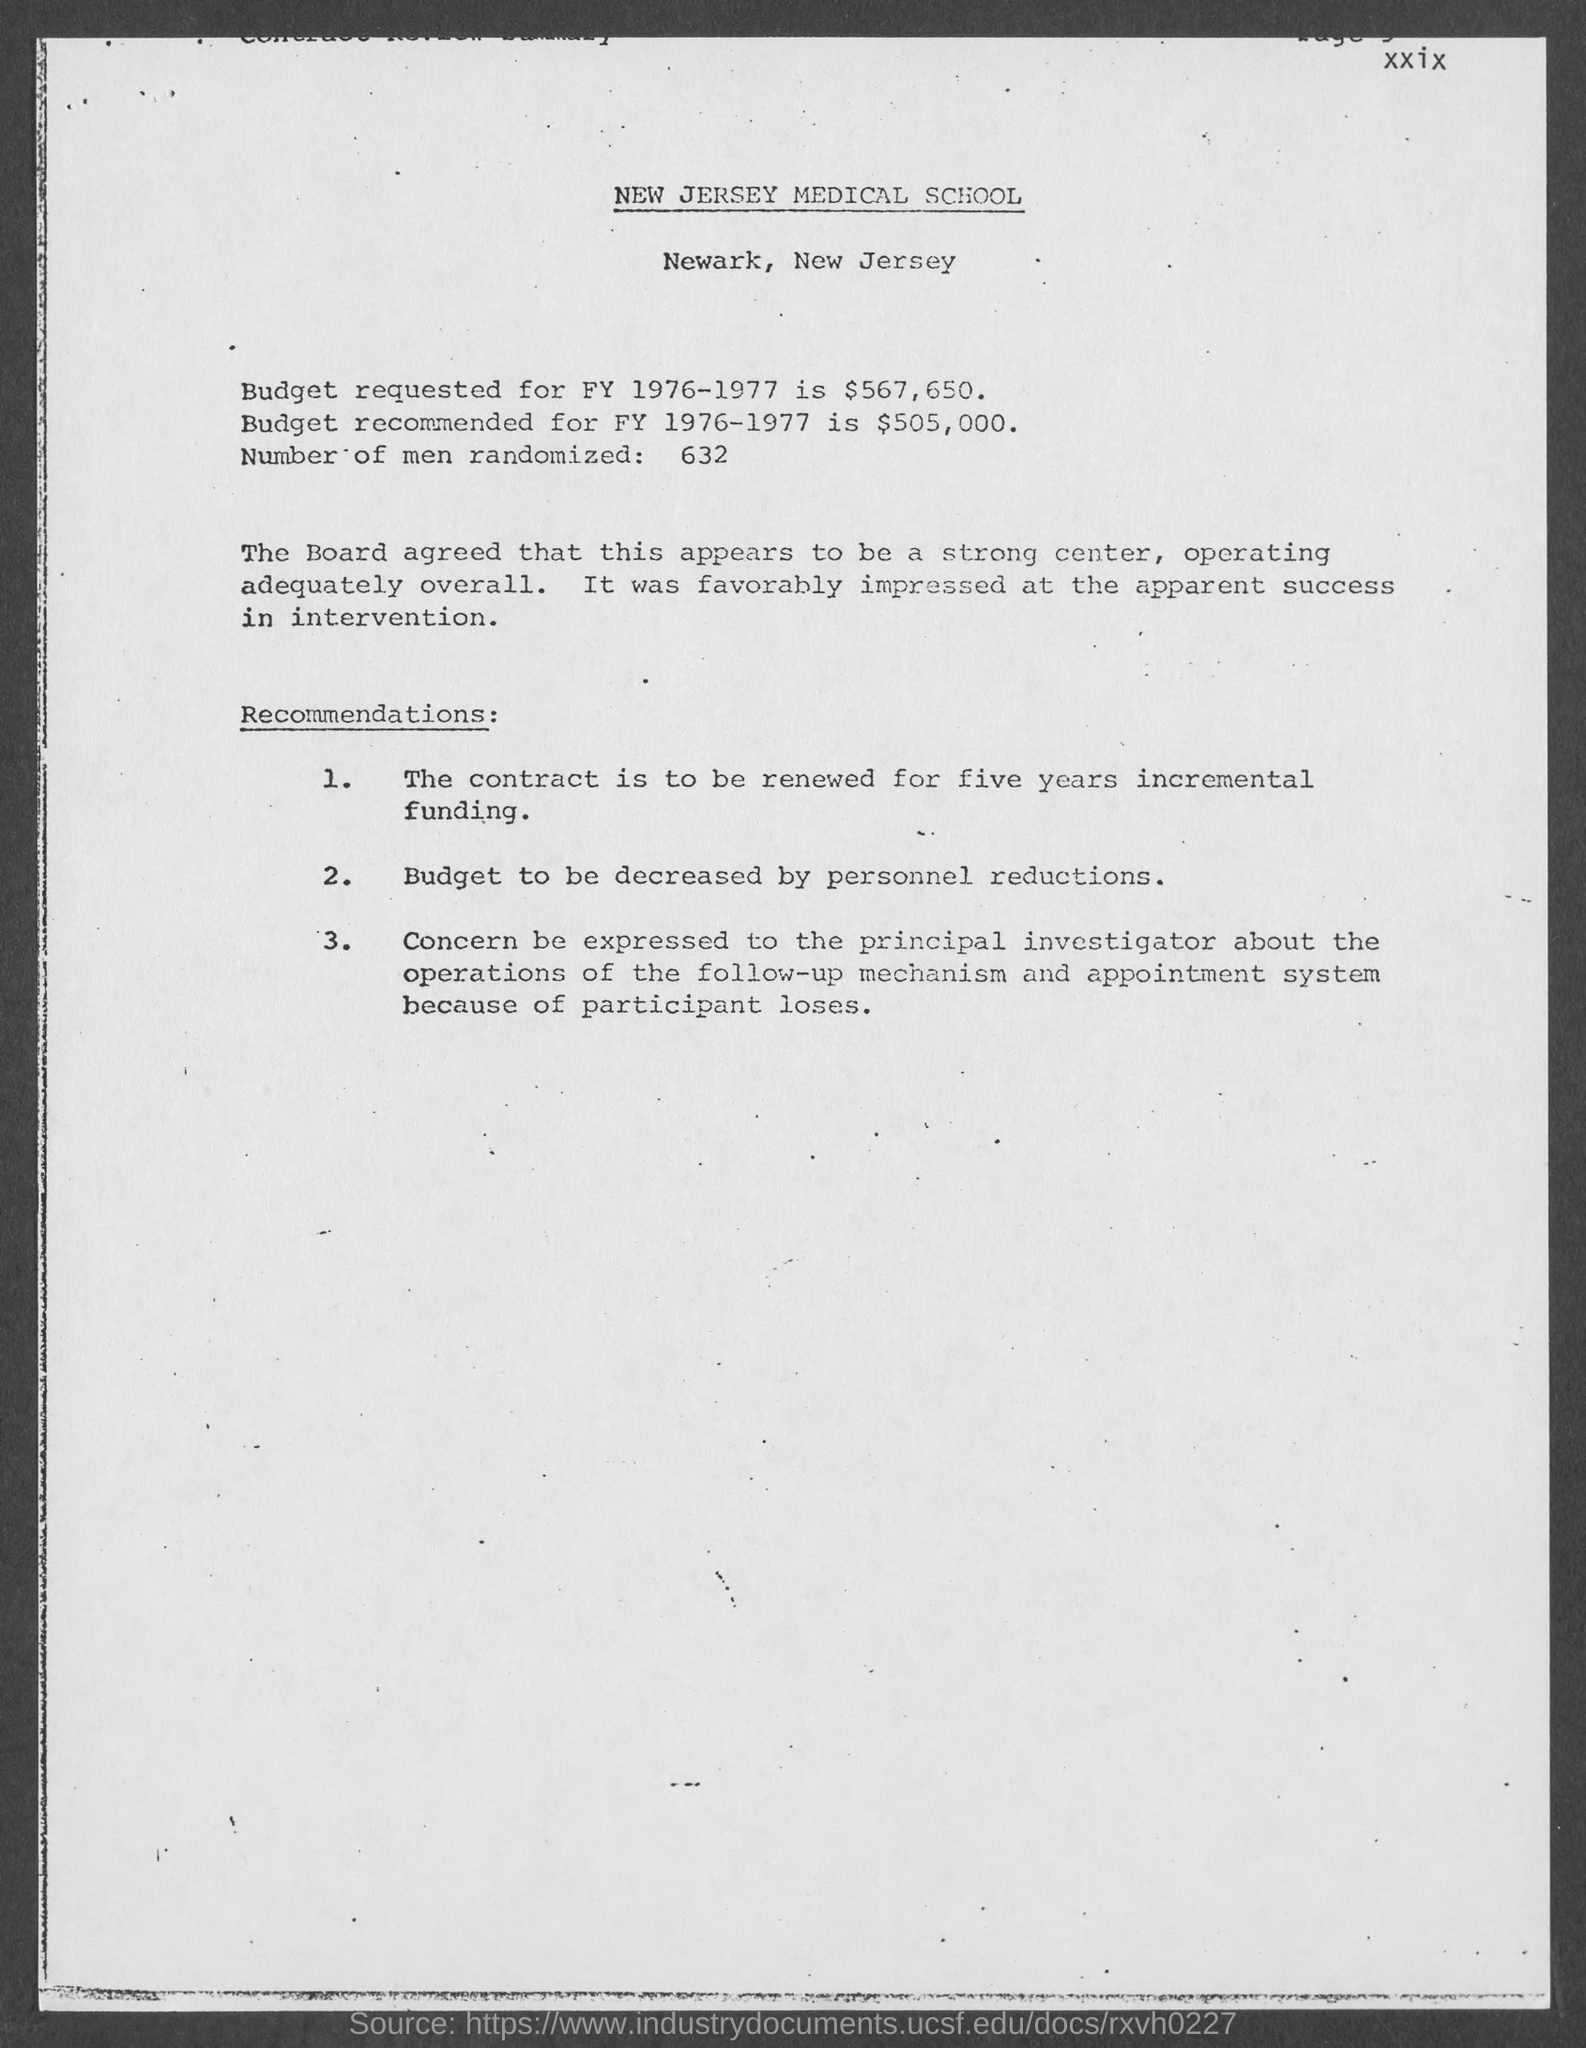What is the number of men randomized as per the document?
 632 